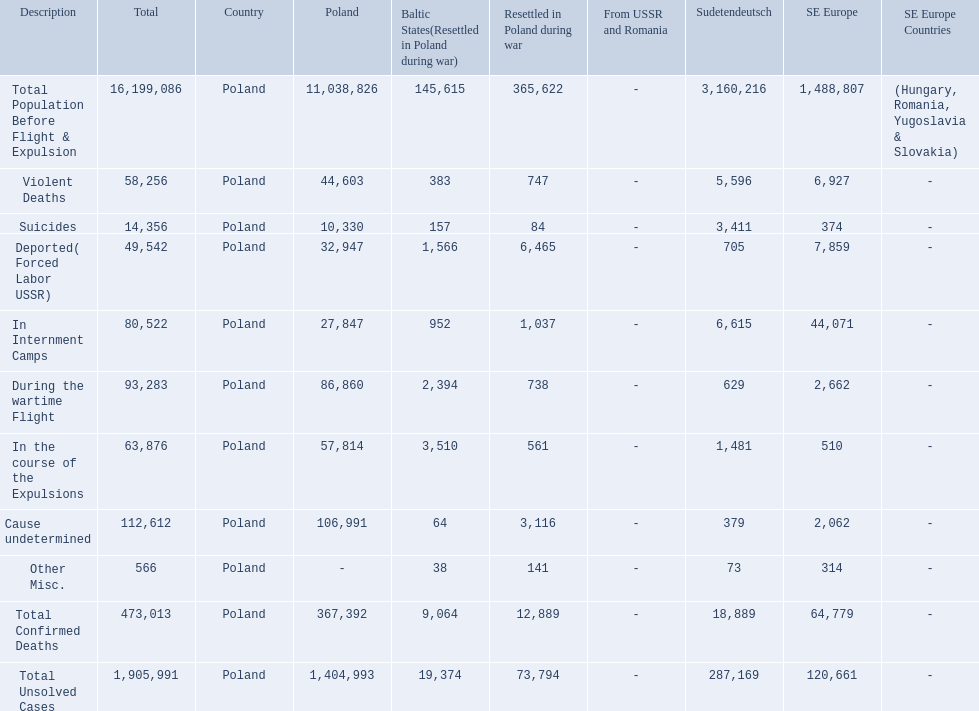What are the numbers of violent deaths across the area? 44,603, 383, 747, 5,596, 6,927. What is the total number of violent deaths of the area? 58,256. 